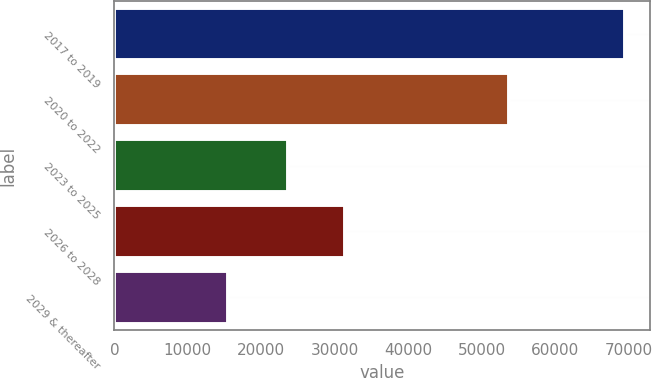Convert chart. <chart><loc_0><loc_0><loc_500><loc_500><bar_chart><fcel>2017 to 2019<fcel>2020 to 2022<fcel>2023 to 2025<fcel>2026 to 2028<fcel>2029 & thereafter<nl><fcel>69408<fcel>53637<fcel>23644<fcel>31416<fcel>15465<nl></chart> 